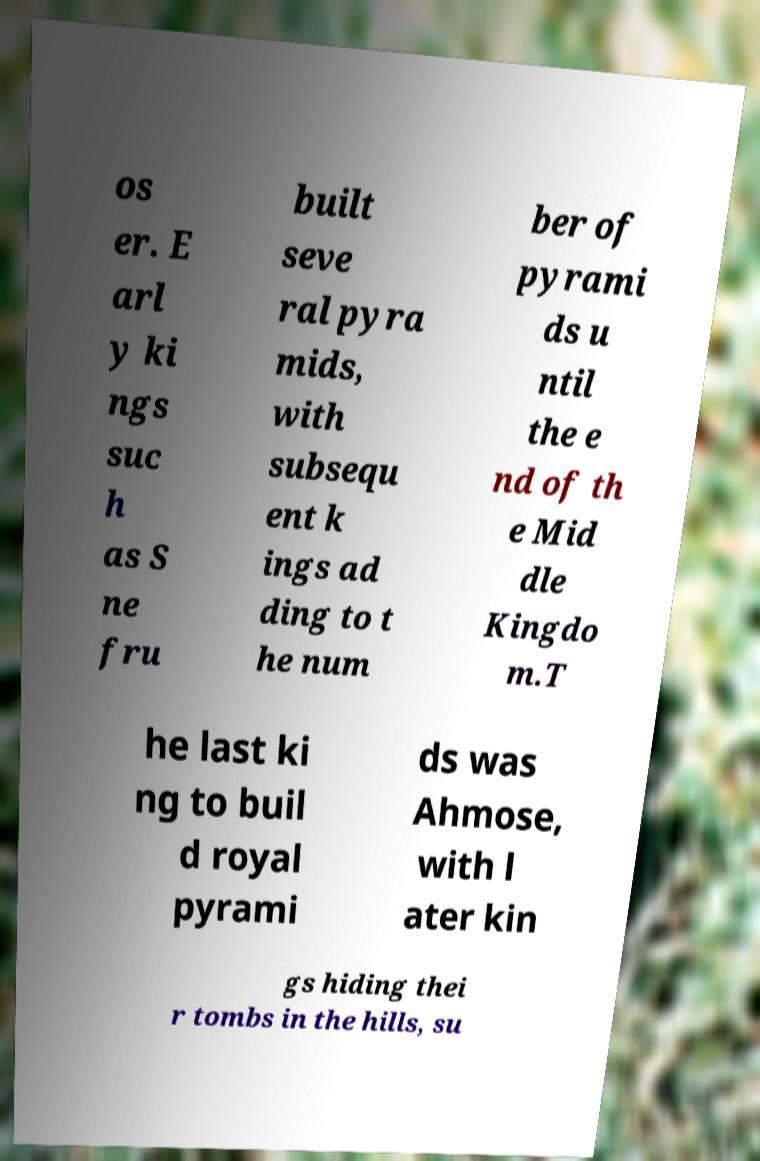Could you assist in decoding the text presented in this image and type it out clearly? os er. E arl y ki ngs suc h as S ne fru built seve ral pyra mids, with subsequ ent k ings ad ding to t he num ber of pyrami ds u ntil the e nd of th e Mid dle Kingdo m.T he last ki ng to buil d royal pyrami ds was Ahmose, with l ater kin gs hiding thei r tombs in the hills, su 